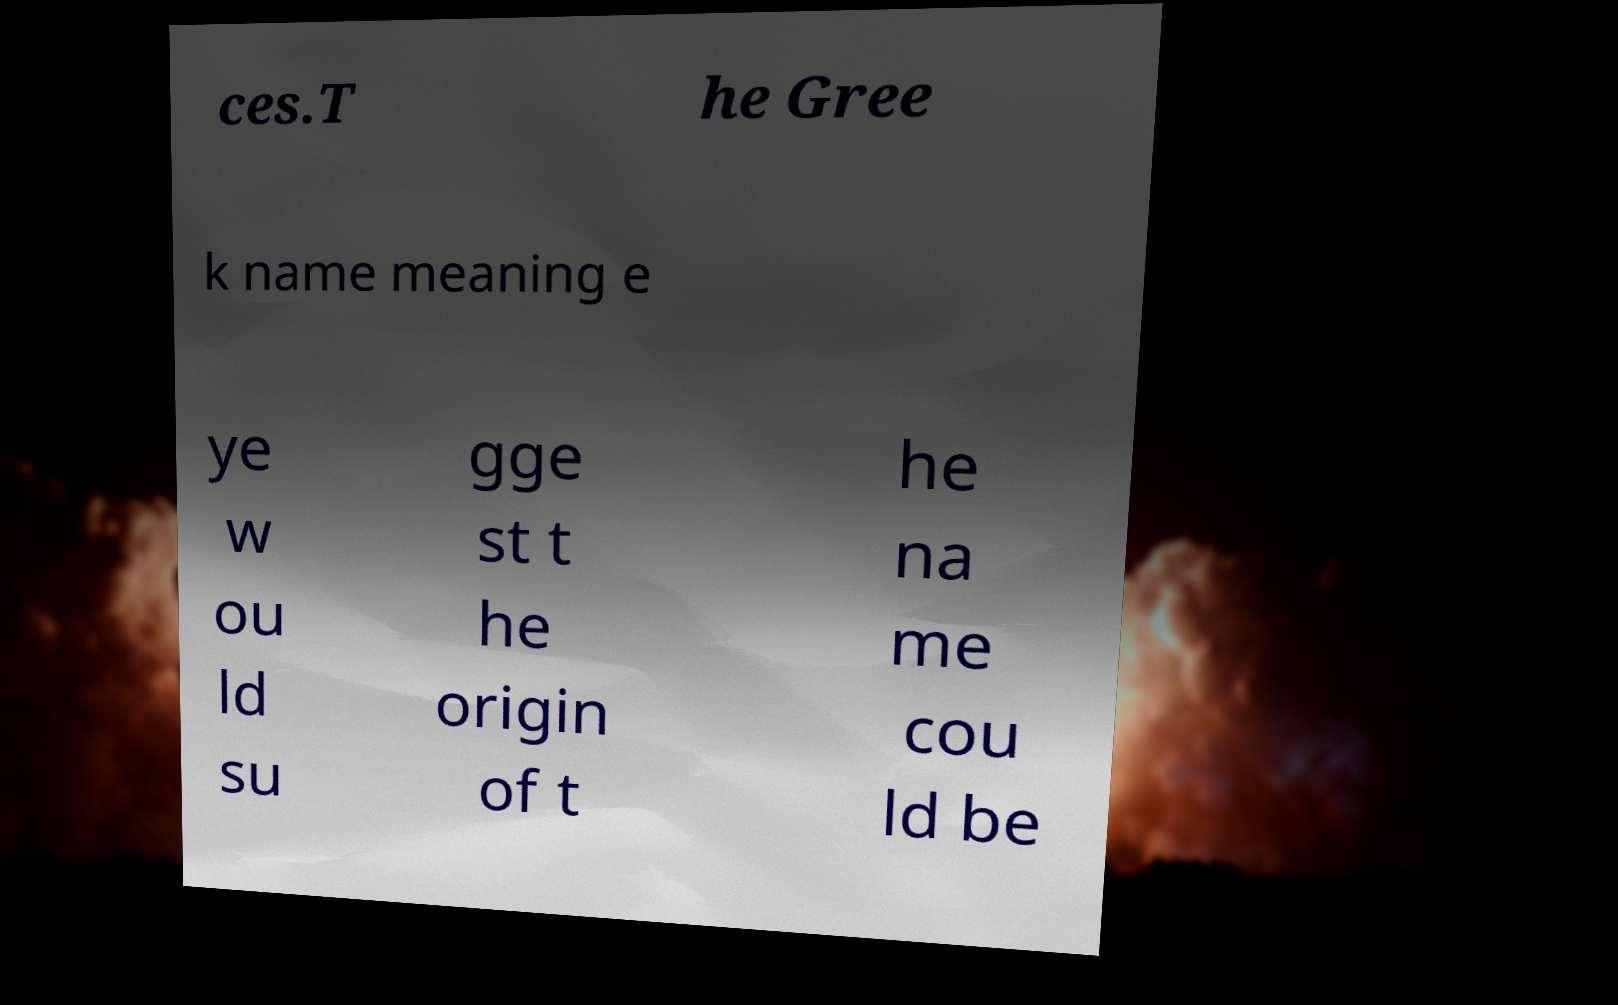Could you assist in decoding the text presented in this image and type it out clearly? ces.T he Gree k name meaning e ye w ou ld su gge st t he origin of t he na me cou ld be 